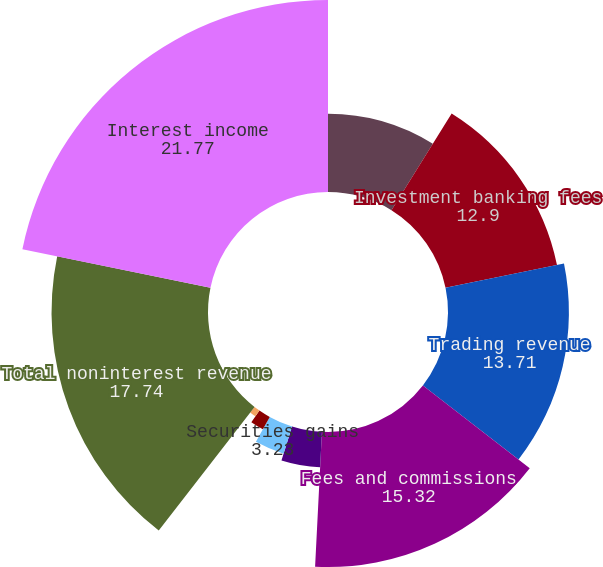Convert chart to OTSL. <chart><loc_0><loc_0><loc_500><loc_500><pie_chart><fcel>Year ended December 31 (in<fcel>Investment banking fees<fcel>Trading revenue<fcel>Fees and commissions<fcel>Private equity gains (losses)<fcel>Securities gains<fcel>Mortgage fees and related<fcel>Other revenue<fcel>Total noninterest revenue<fcel>Interest income<nl><fcel>8.87%<fcel>12.9%<fcel>13.71%<fcel>15.32%<fcel>4.03%<fcel>3.23%<fcel>1.61%<fcel>0.81%<fcel>17.74%<fcel>21.77%<nl></chart> 